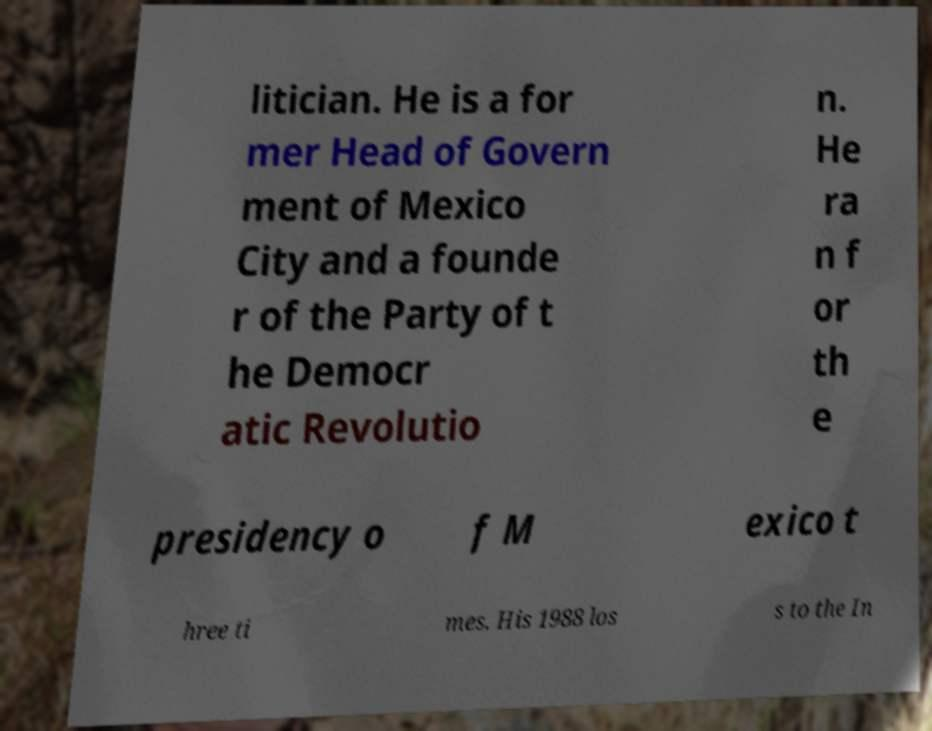Please read and relay the text visible in this image. What does it say? litician. He is a for mer Head of Govern ment of Mexico City and a founde r of the Party of t he Democr atic Revolutio n. He ra n f or th e presidency o f M exico t hree ti mes. His 1988 los s to the In 